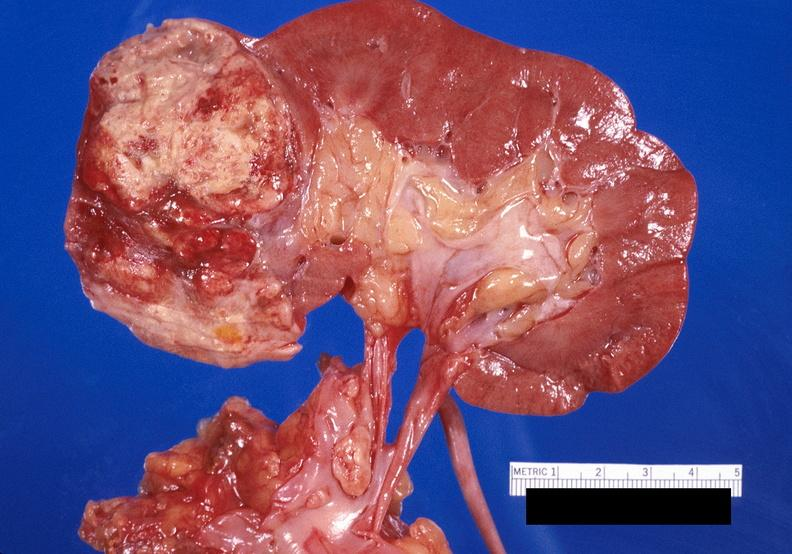does this image show renal cell carcinoma with extension into vena cava?
Answer the question using a single word or phrase. Yes 